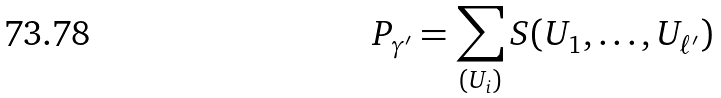<formula> <loc_0><loc_0><loc_500><loc_500>P _ { \gamma ^ { \prime } } = \sum _ { ( U _ { i } ) } S ( U _ { 1 } , \dots , U _ { \ell ^ { \prime } } )</formula> 